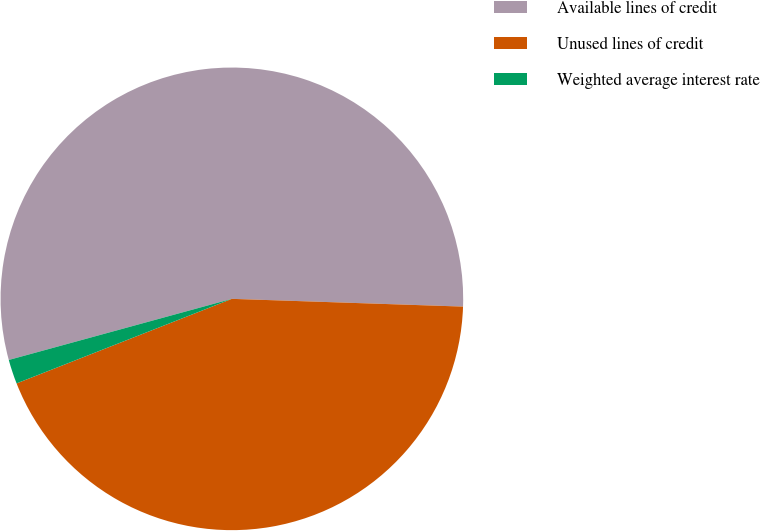Convert chart. <chart><loc_0><loc_0><loc_500><loc_500><pie_chart><fcel>Available lines of credit<fcel>Unused lines of credit<fcel>Weighted average interest rate<nl><fcel>54.79%<fcel>43.51%<fcel>1.7%<nl></chart> 